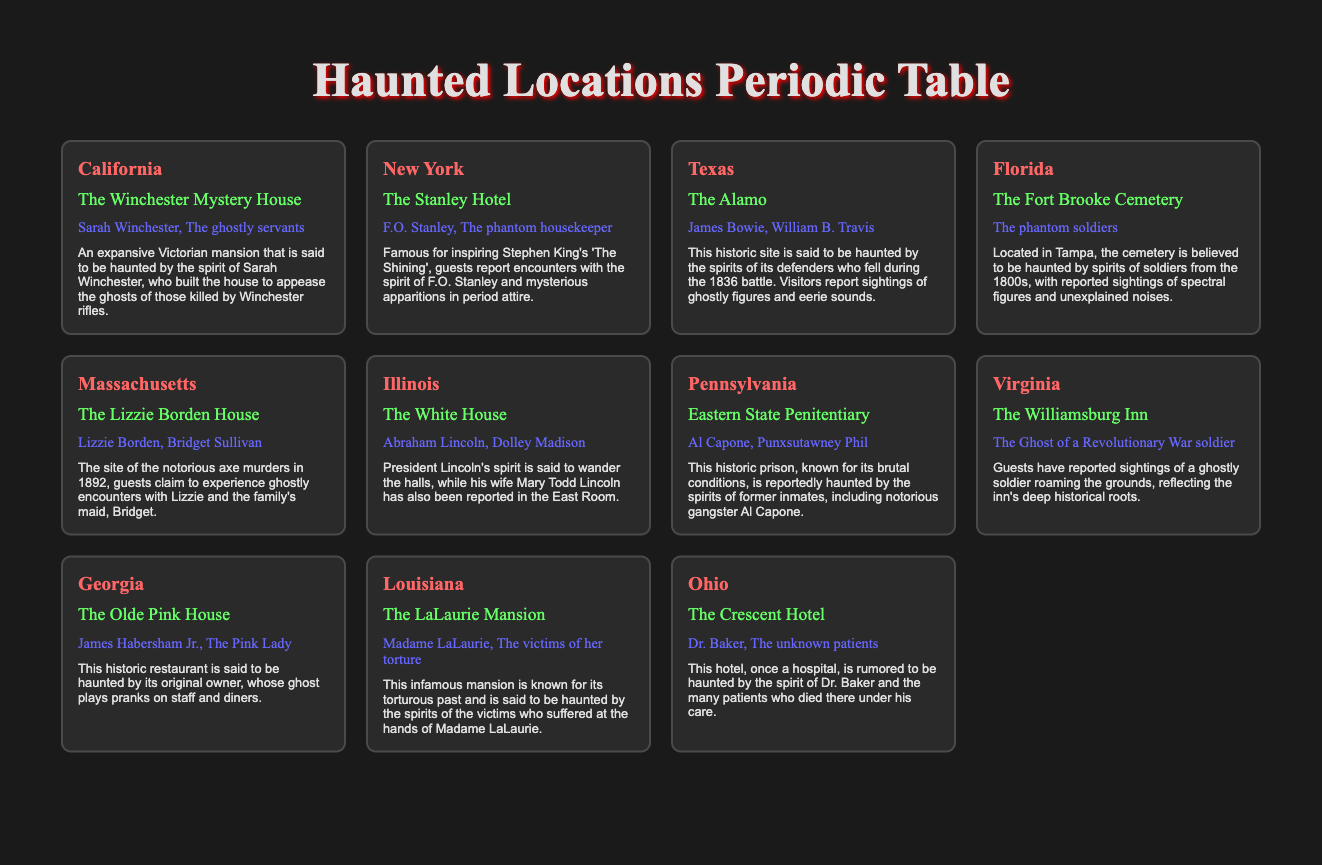What is the notable ghost associated with The Alamo in Texas? The notable ghosts listed for The Alamo are James Bowie and William B. Travis.
Answer: James Bowie, William B. Travis How many haunted locations are listed in California? There is one haunted location listed in California, which is The Winchester Mystery House.
Answer: 1 True or False: The Lizzie Borden House is haunted by a ghost named Bridget Sullivan. The table indicates that Bridget Sullivan is indeed one of the notable ghosts at The Lizzie Borden House, so the statement is true.
Answer: True Which location is noted for having the ghost of a Revolutionary War soldier? The Williamsburg Inn in Virginia is noted for having the ghost of a Revolutionary War soldier.
Answer: The Williamsburg Inn If you combine the notable ghosts from The Winchester Mystery House and The Alamo, how many different names do you have? The Winchester Mystery House has two notable ghosts: Sarah Winchester and The ghostly servants. The Alamo has two notable ghosts: James Bowie and William B. Travis. Combining these gives us four different names since there are no overlapping ghosts.
Answer: 4 Which state has a haunted location associated with F.O. Stanley? F.O. Stanley is the notable ghost associated with The Stanley Hotel, which is located in New York.
Answer: New York True or False: The LaLaurie Mansion is haunted by the ghosts of the victims of Madame LaLaurie. According to the table, The LaLaurie Mansion is indeed haunted by the victims of her torture, making this statement true.
Answer: True What is the description of The Crescent Hotel located in Ohio? The Crescent Hotel is described as a hotel that was once a hospital and is rumored to be haunted by the spirit of Dr. Baker and the many patients who died there under his care.
Answer: A hotel once a hospital haunted by Dr. Baker and patients 